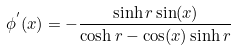Convert formula to latex. <formula><loc_0><loc_0><loc_500><loc_500>\phi ^ { ^ { \prime } } ( x ) = - \frac { \sinh r \sin ( x ) } { \cosh r - \cos ( x ) \sinh r }</formula> 